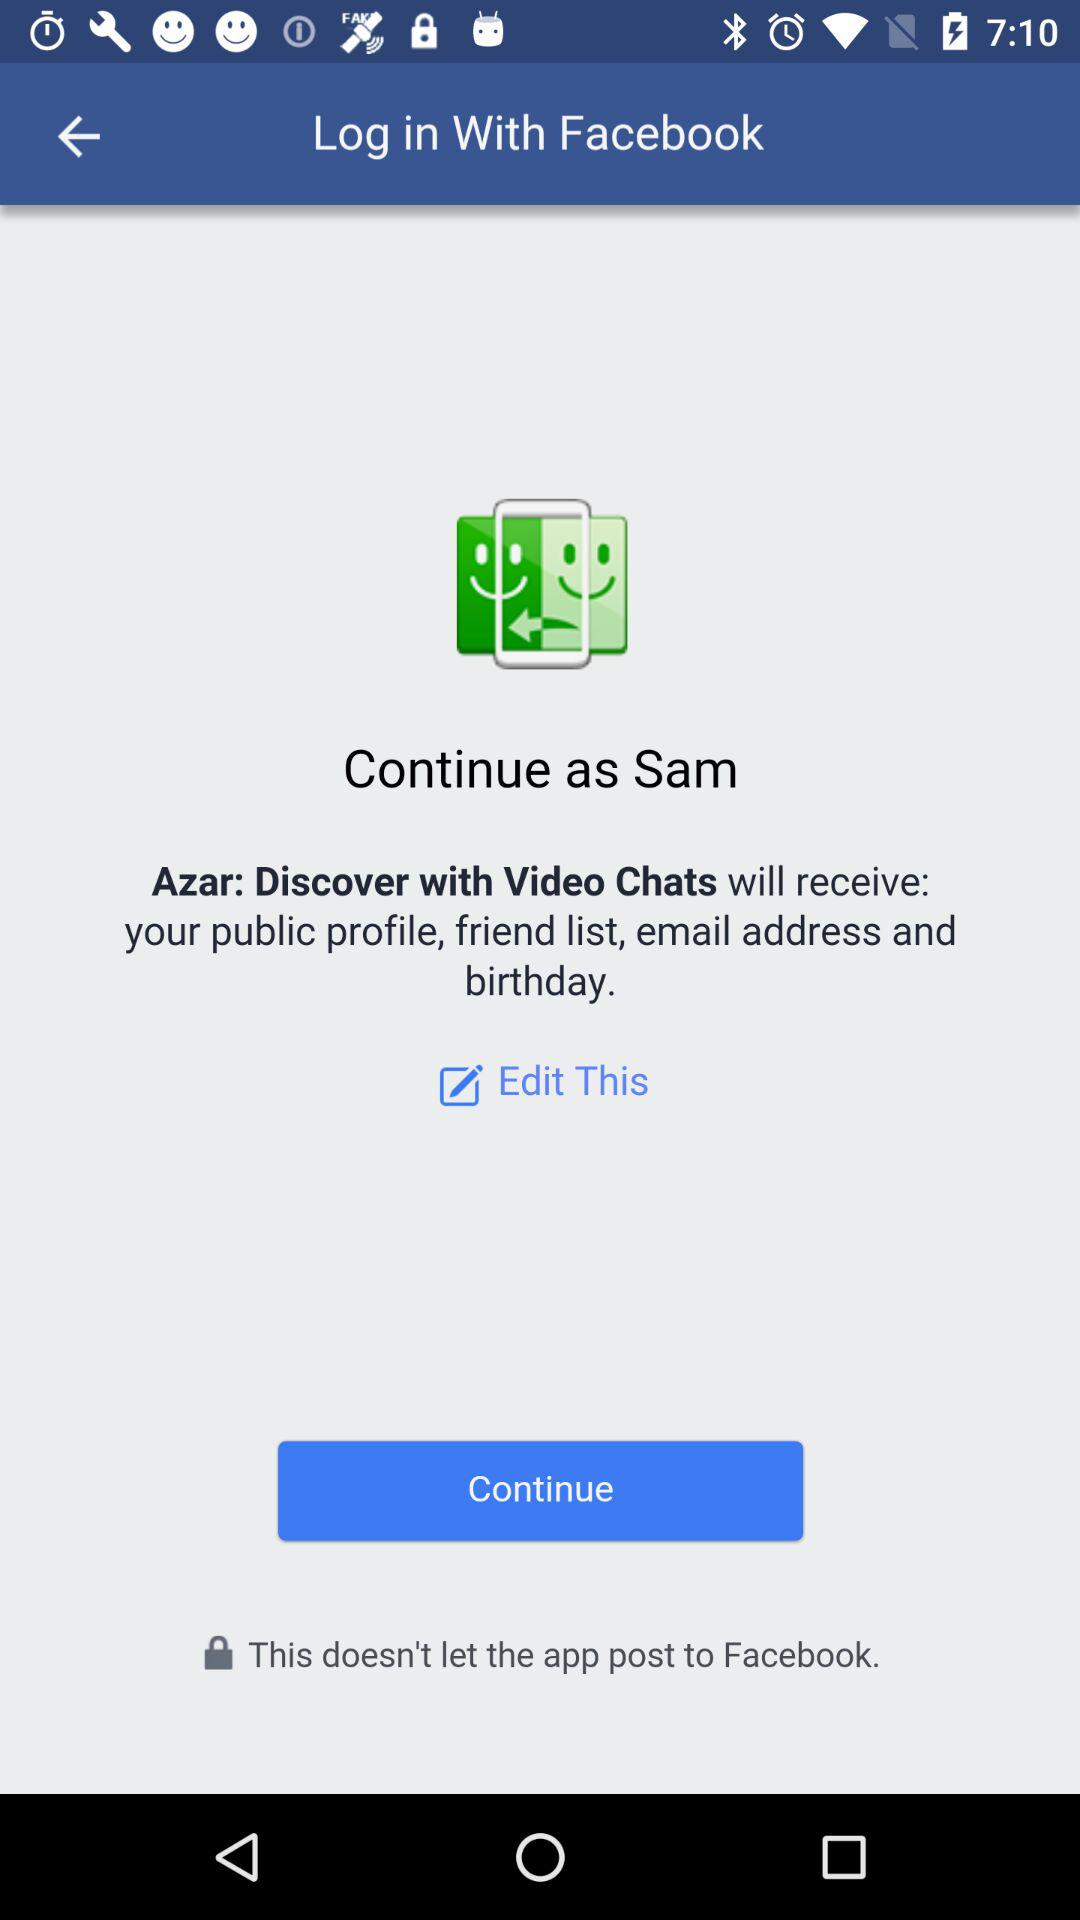How many smiley faces are on the screen?
Answer the question using a single word or phrase. 2 